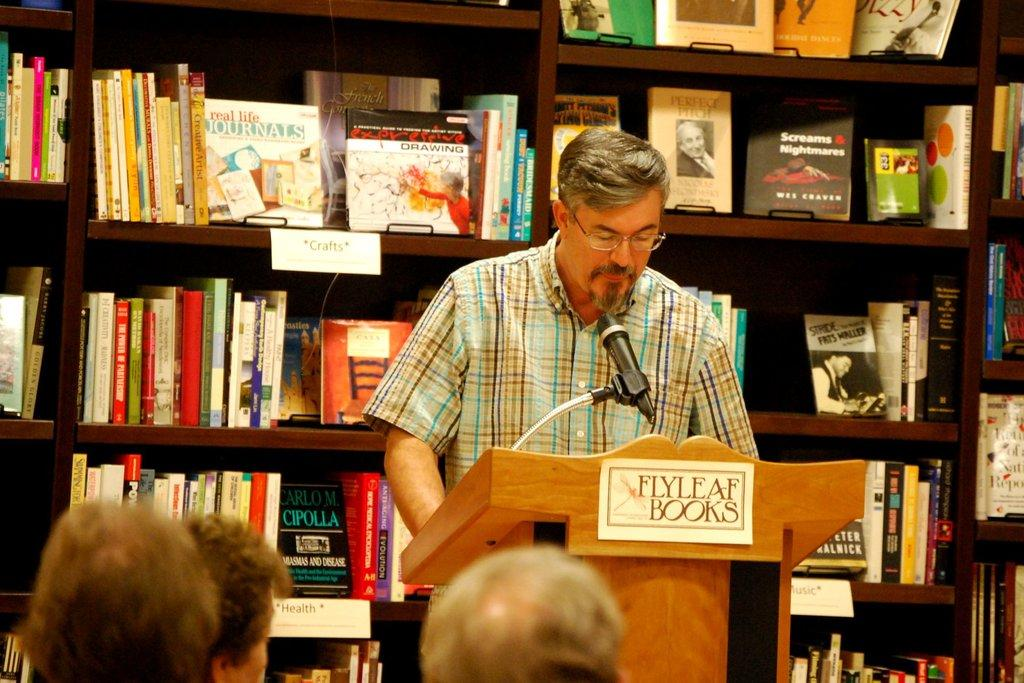<image>
Render a clear and concise summary of the photo. the word books is on the stand in front of the man 